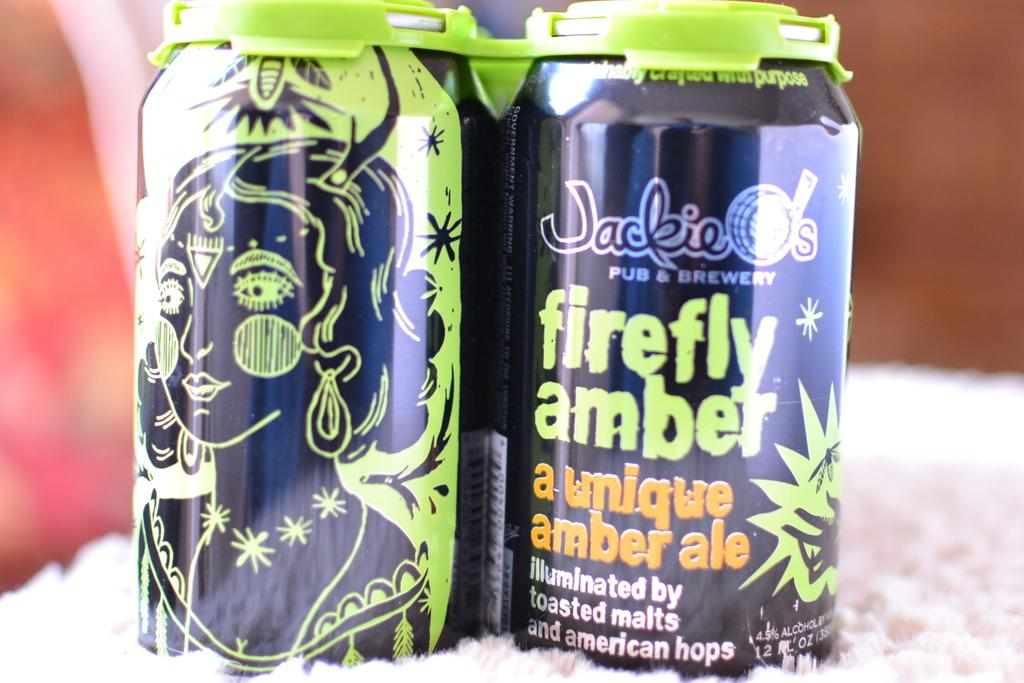<image>
Provide a brief description of the given image. Two purple and green cans of Jackie O's Firefly Amber ale. 